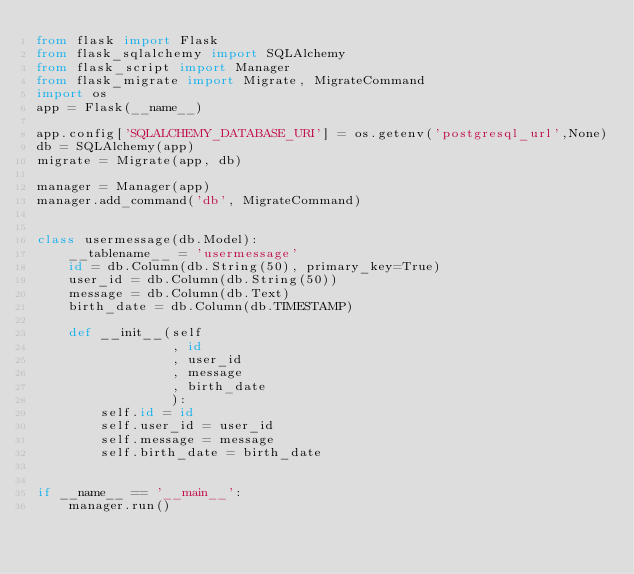<code> <loc_0><loc_0><loc_500><loc_500><_Python_>from flask import Flask
from flask_sqlalchemy import SQLAlchemy
from flask_script import Manager
from flask_migrate import Migrate, MigrateCommand
import os
app = Flask(__name__)

app.config['SQLALCHEMY_DATABASE_URI'] = os.getenv('postgresql_url',None)
db = SQLAlchemy(app)
migrate = Migrate(app, db)

manager = Manager(app)
manager.add_command('db', MigrateCommand)


class usermessage(db.Model):
    __tablename__ = 'usermessage'
    id = db.Column(db.String(50), primary_key=True)
    user_id = db.Column(db.String(50))
    message = db.Column(db.Text)
    birth_date = db.Column(db.TIMESTAMP)

    def __init__(self
                 , id
                 , user_id
                 , message
                 , birth_date
                 ):
        self.id = id
        self.user_id = user_id
        self.message = message
        self.birth_date = birth_date


if __name__ == '__main__':
    manager.run()</code> 